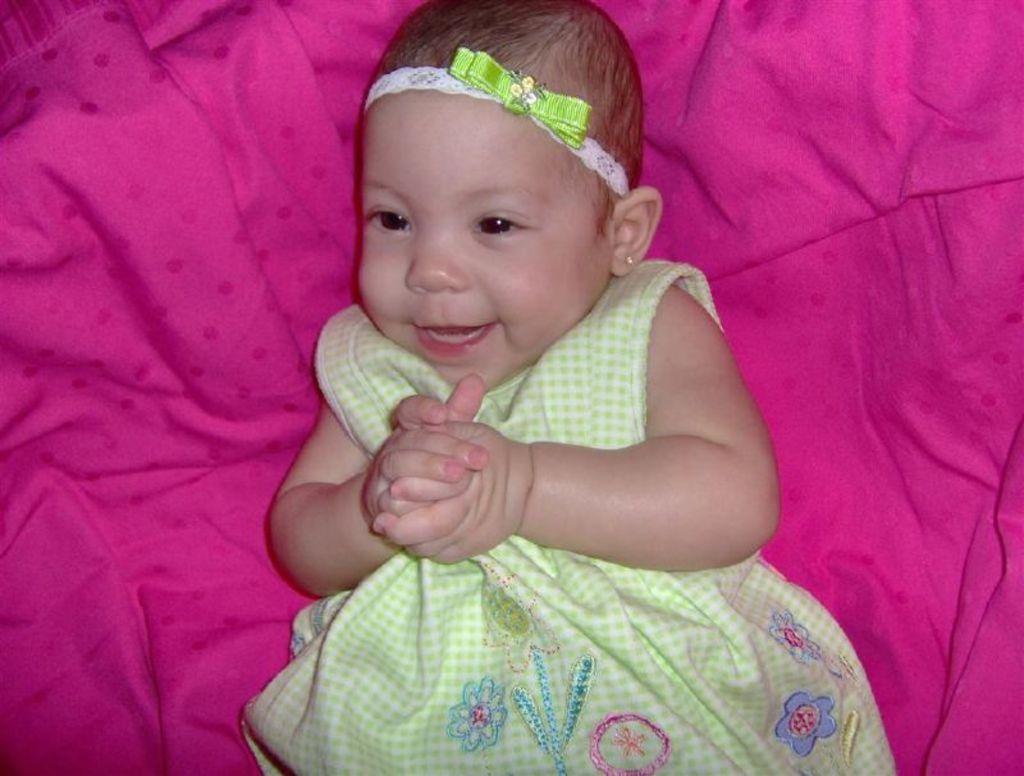Can you describe this image briefly? In the image we can see a baby wearing clothes, ear studs and the baby is lying on the pink cloth. 